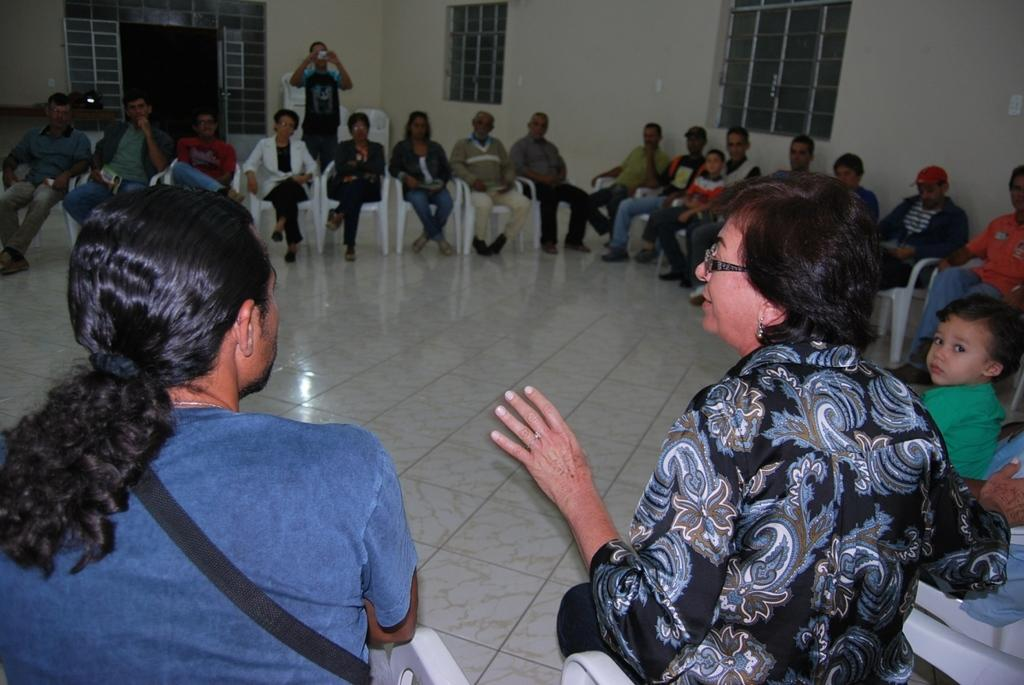What are the people in the image doing? The people in the image are sitting and watching something. Who is standing behind the sitting people? There is a man standing behind the sitting people. What is the man holding? The man is holding a camera. What can be seen on the wall in the image? There are windows on the wall in the image. What type of underwear is the man wearing in the image? There is no information about the man's underwear in the image, as it is not visible or mentioned in the provided facts. 